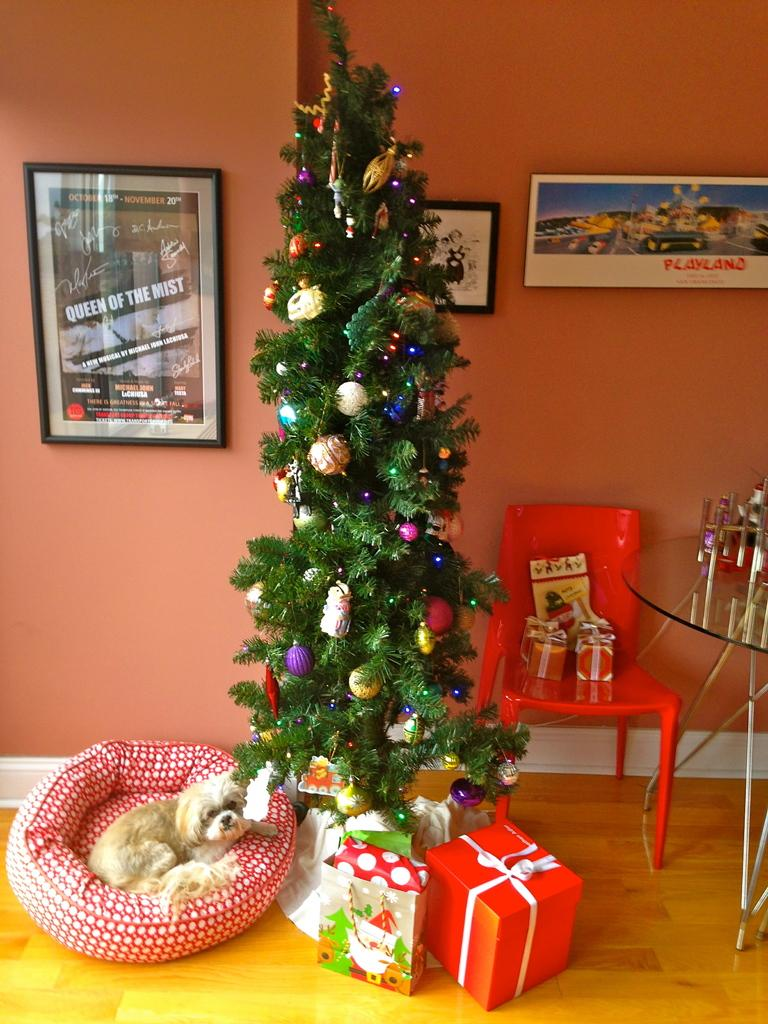What is the main subject in the middle of the image? There is a Christmas tree in the middle of the image. Can you describe the location of the dog in the image? The dog is beside a frame on the wall. What type of meat is hanging from the Christmas tree in the image? There is no meat hanging from the Christmas tree in the image; it is a decorated tree with no food items present. 